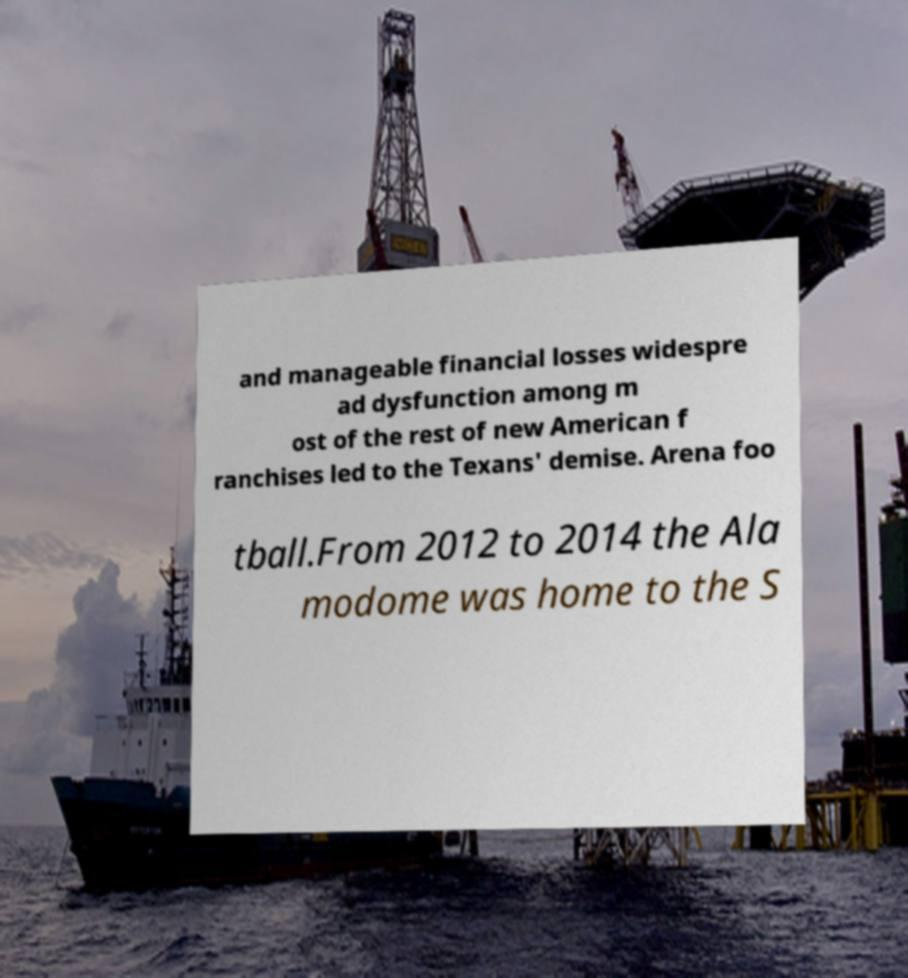Please identify and transcribe the text found in this image. and manageable financial losses widespre ad dysfunction among m ost of the rest of new American f ranchises led to the Texans' demise. Arena foo tball.From 2012 to 2014 the Ala modome was home to the S 